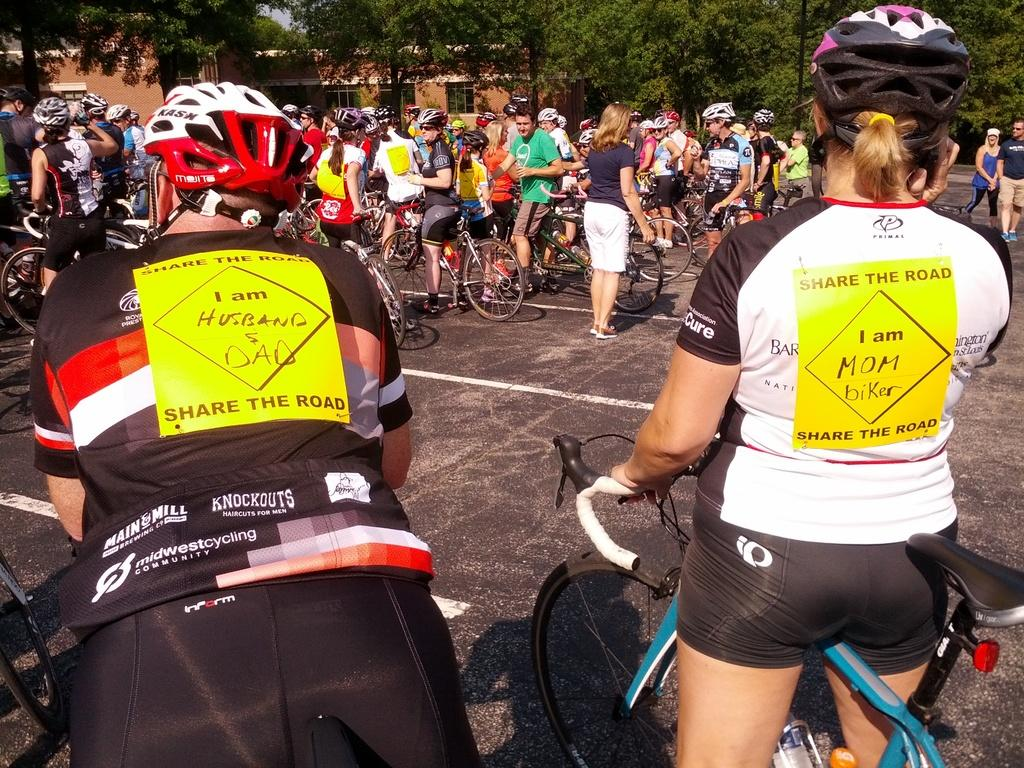What type of vehicles are in the image? There are bicycles in the image. Who is present in the image? There is a group of people in the image. What type of structures can be seen in the image? There are houses in the image. What type of vegetation is in the image? There are trees in the image. What type of crow can be seen in the image? There is no crow present in the image. How does the group of people look in the image? The question is too vague and subjective; the image only shows that there is a group of people present. Is the image hot? The concept of "hot" cannot be applied to an image; it is a description of temperature, which is not relevant to the visual content of the image. 